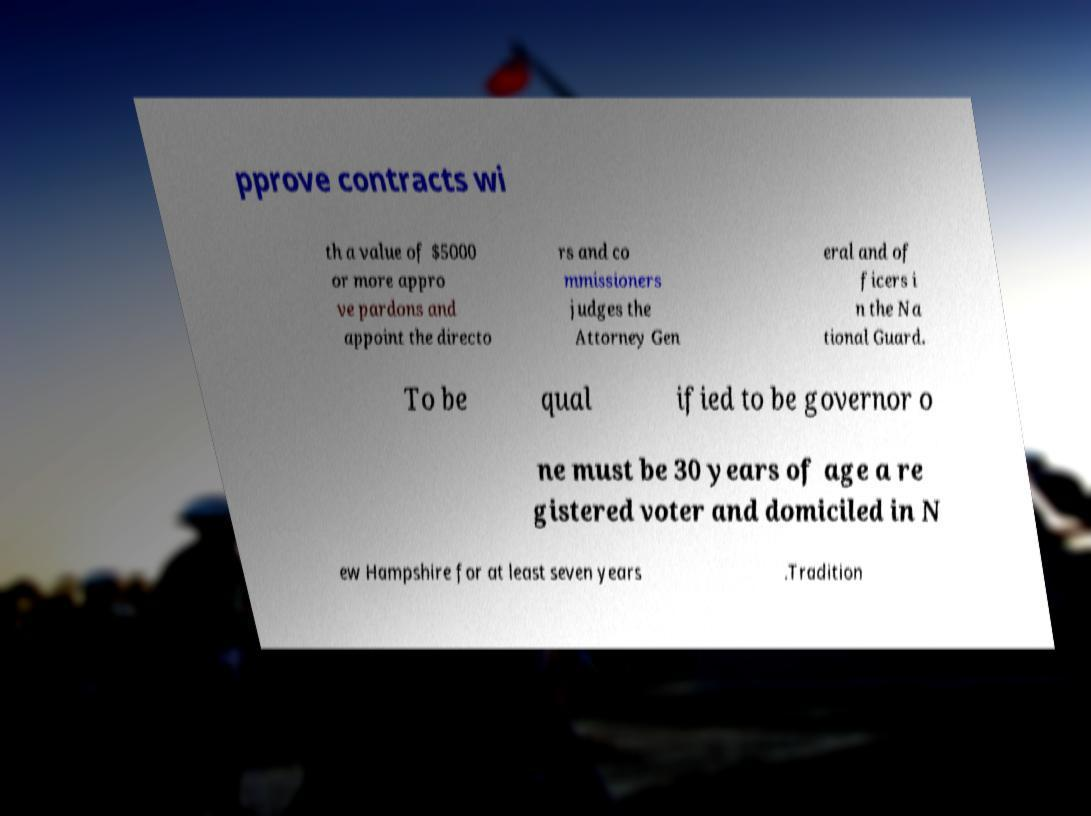Can you read and provide the text displayed in the image?This photo seems to have some interesting text. Can you extract and type it out for me? pprove contracts wi th a value of $5000 or more appro ve pardons and appoint the directo rs and co mmissioners judges the Attorney Gen eral and of ficers i n the Na tional Guard. To be qual ified to be governor o ne must be 30 years of age a re gistered voter and domiciled in N ew Hampshire for at least seven years .Tradition 